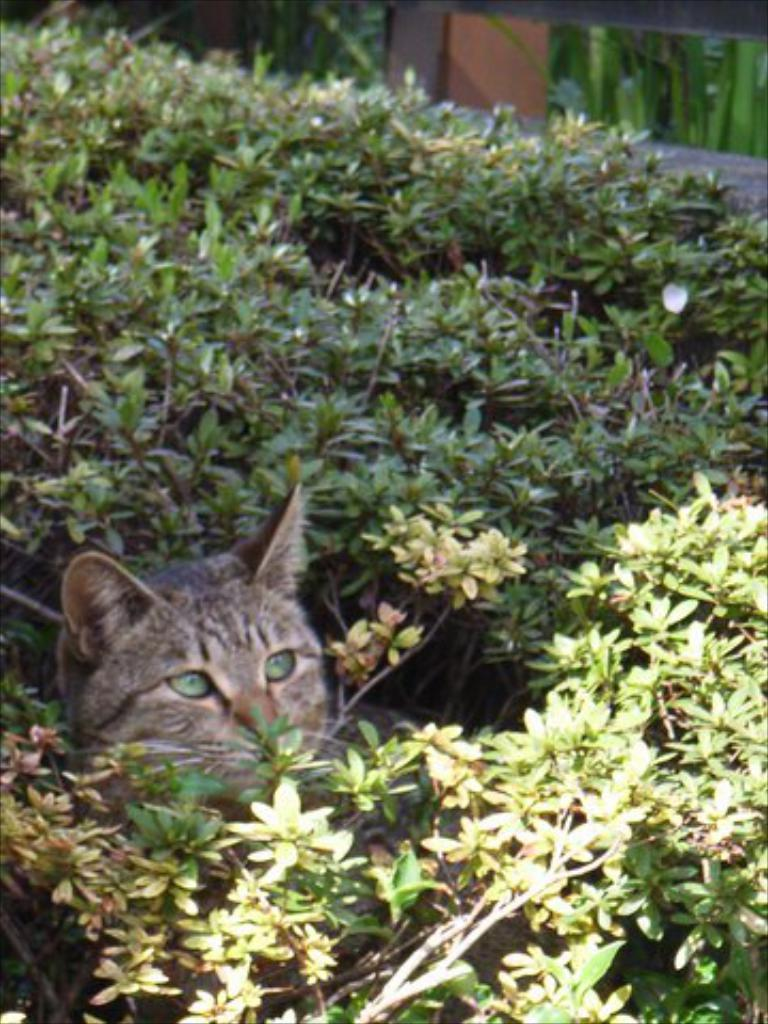What type of plants can be seen in the image? There are green color plants in the image. What animal is present in the image? There is a cat sitting in the image. Where is the cat located in relation to the plants? The cat is located between the plants. What level of education does the cat have in the image? The image does not provide information about the cat's education level. In what year was the image taken? The image does not include any information about the year it was taken. 